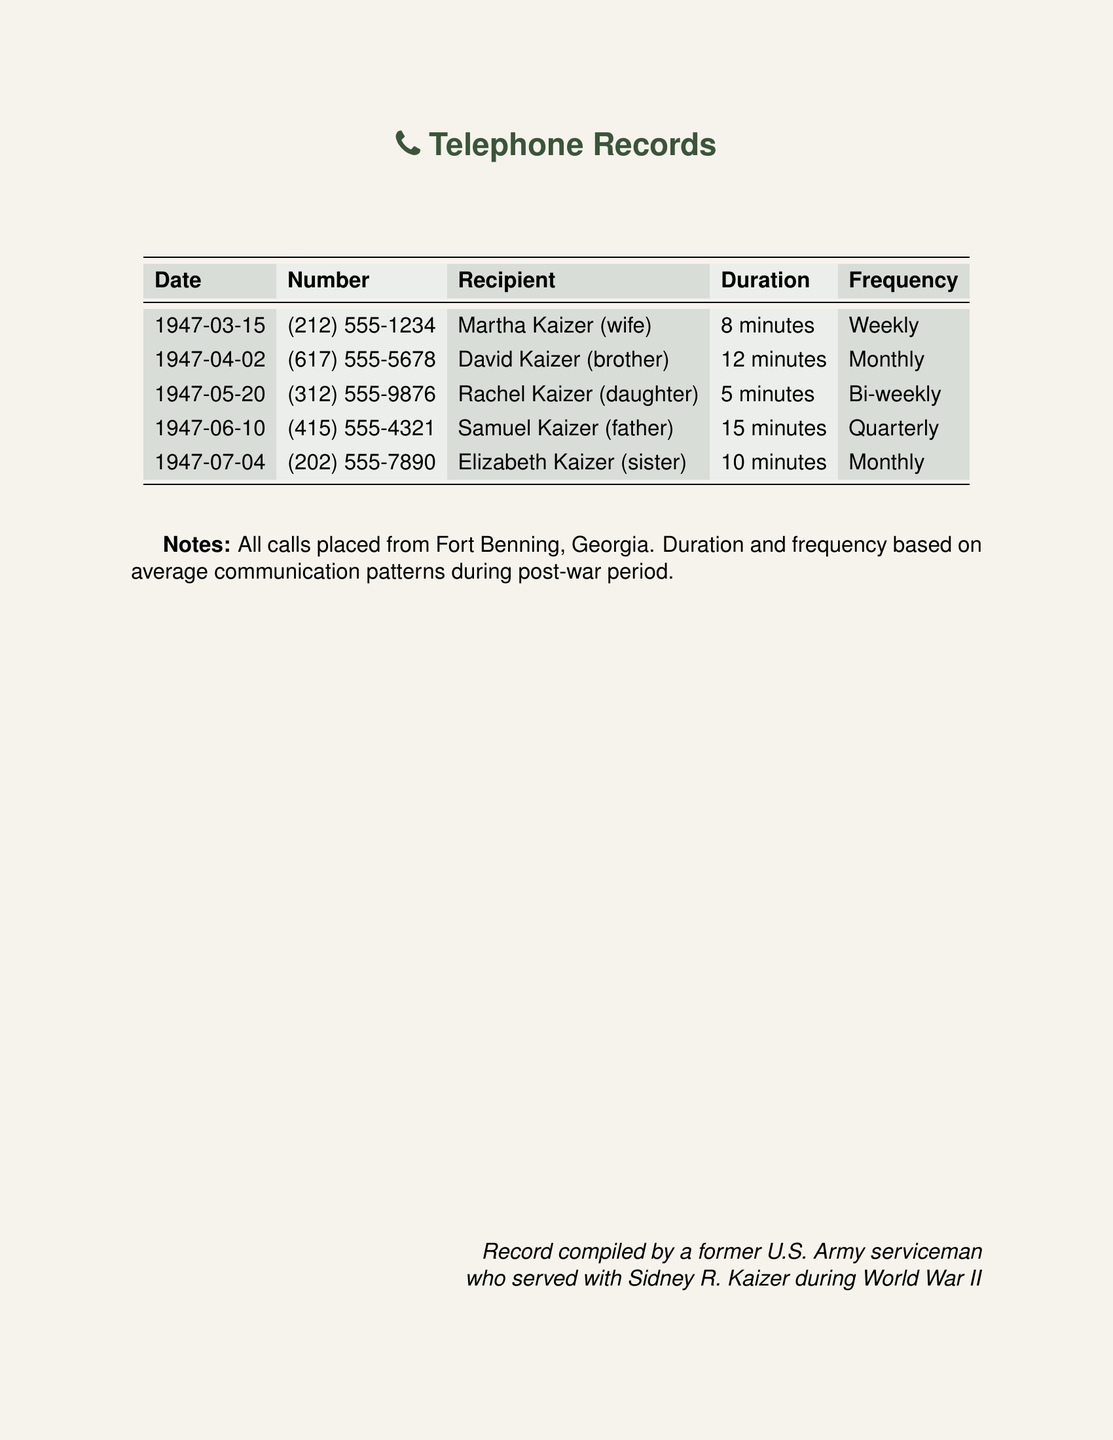What is the first date listed in the records? The first date of an outgoing call recorded is March 15, 1947.
Answer: March 15, 1947 Who received the longest call? The duration of each call shows that Samuel Kaizer (father) received the longest call, lasting 15 minutes.
Answer: Samuel Kaizer How often did Martha Kaizer receive calls? The frequency column indicates that Martha Kaizer (wife) received calls weekly.
Answer: Weekly What was the duration of the call to Rachel Kaizer? The document states the duration of the call to Rachel Kaizer (daughter) was 5 minutes.
Answer: 5 minutes How many calls were made monthly? The records indicate that there were two calls made monthly to David and Elizabeth Kaizer.
Answer: 2 What is the phone number for David Kaizer? The document specifies the number for David Kaizer (brother) as (617) 555-5678.
Answer: (617) 555-5678 Which family member had a call frequency of quarterly? According to the frequency information, Samuel Kaizer (father) had a quarterly call frequency.
Answer: Samuel Kaizer How many minutes total were spent on calls to siblings? The total duration for calls to siblings (Martha 8 min, David 12 min, Elizabeth 10 min) adds up to 30 minutes.
Answer: 30 minutes 